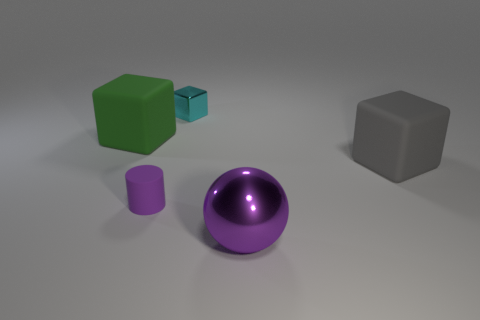Subtract all big green rubber blocks. How many blocks are left? 2 Add 2 green blocks. How many objects exist? 7 Subtract 1 blocks. How many blocks are left? 2 Subtract all blocks. How many objects are left? 2 Subtract all brown blocks. Subtract all green spheres. How many blocks are left? 3 Subtract 0 brown balls. How many objects are left? 5 Subtract all big gray metallic spheres. Subtract all large matte things. How many objects are left? 3 Add 5 big gray matte objects. How many big gray matte objects are left? 6 Add 5 large purple rubber spheres. How many large purple rubber spheres exist? 5 